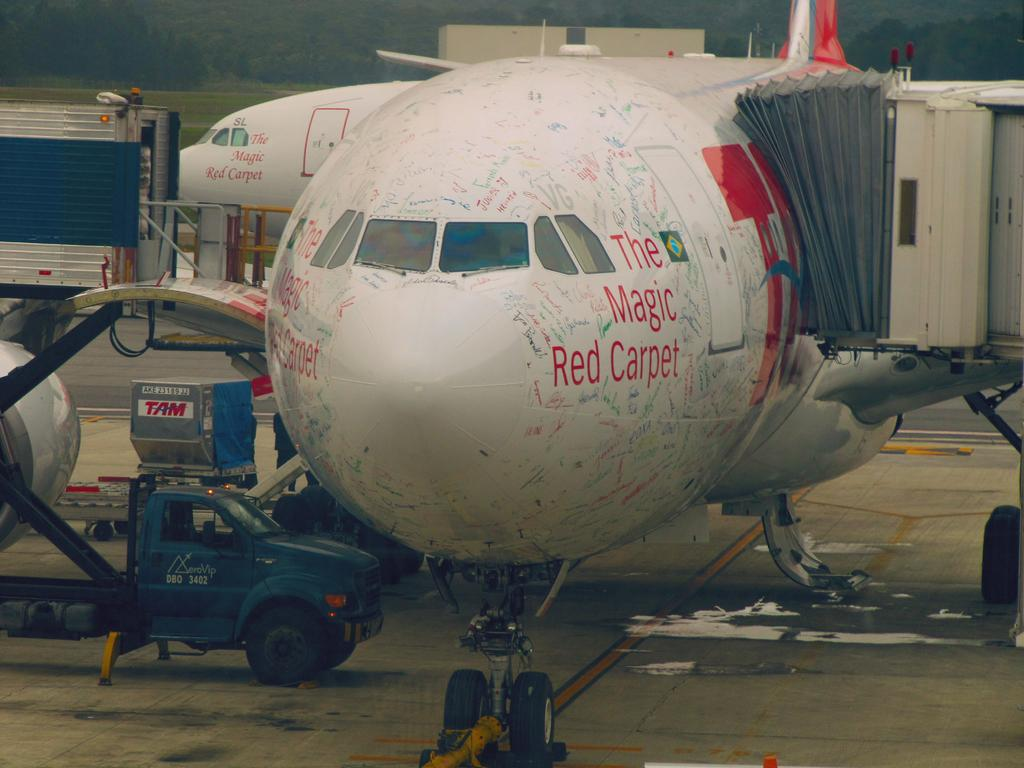<image>
Offer a succinct explanation of the picture presented. Whiet airplane with the words " The Magic Red Carpet " parked. 